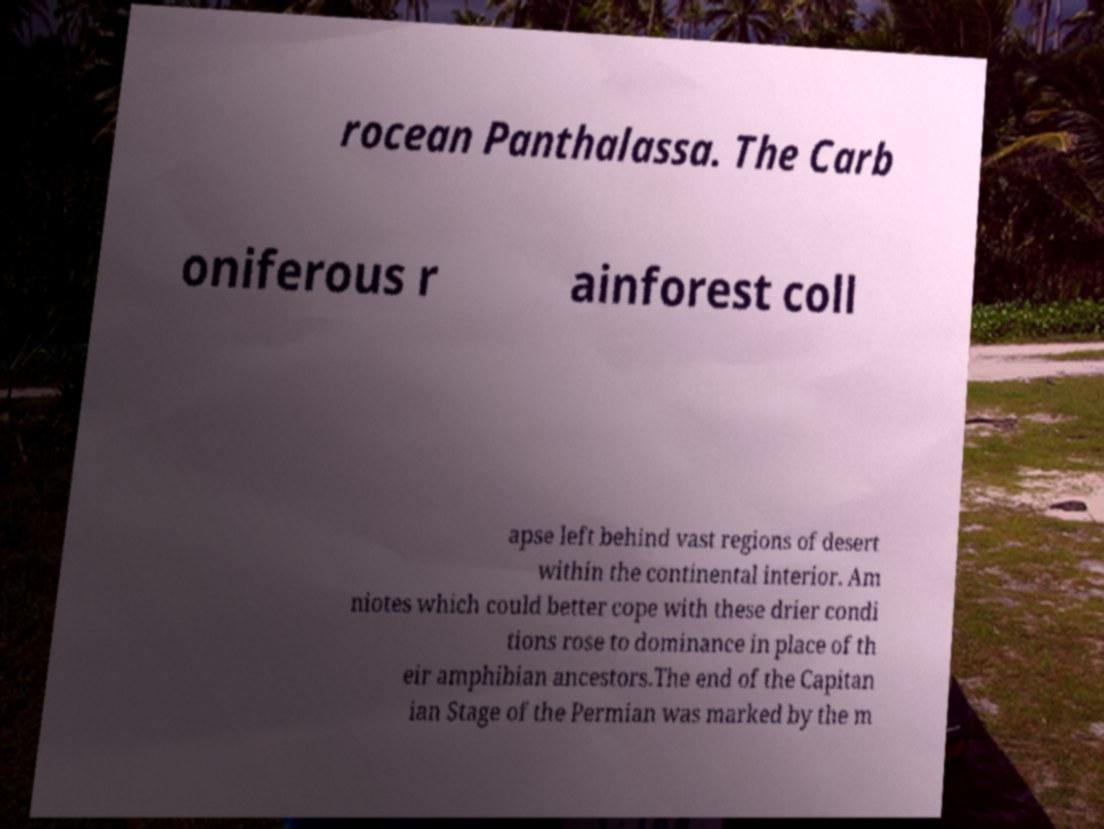Please read and relay the text visible in this image. What does it say? rocean Panthalassa. The Carb oniferous r ainforest coll apse left behind vast regions of desert within the continental interior. Am niotes which could better cope with these drier condi tions rose to dominance in place of th eir amphibian ancestors.The end of the Capitan ian Stage of the Permian was marked by the m 